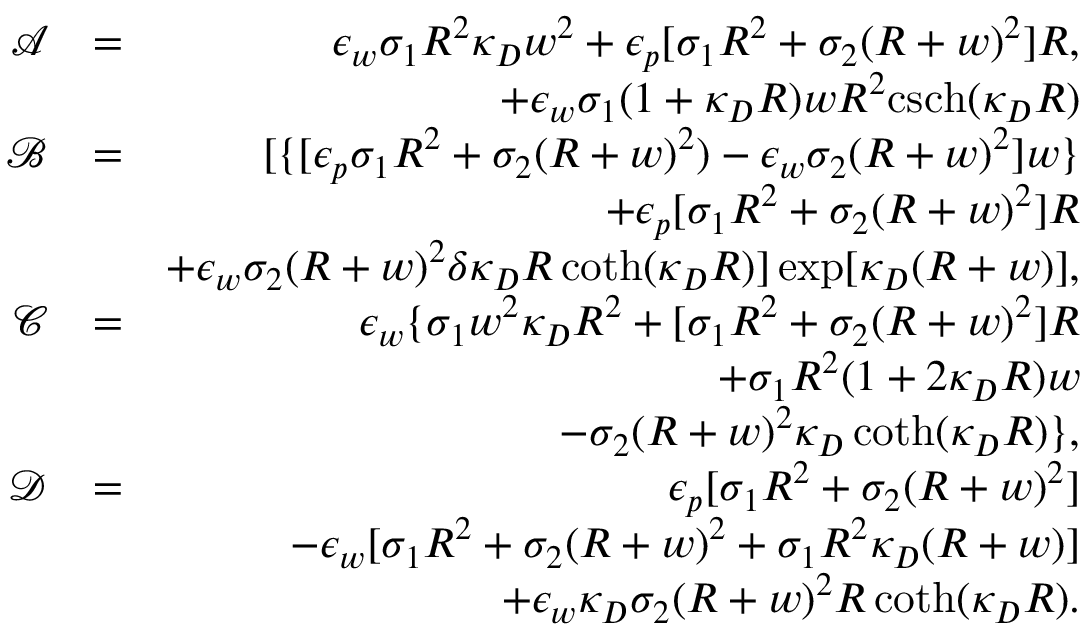Convert formula to latex. <formula><loc_0><loc_0><loc_500><loc_500>\begin{array} { r l r } { \mathcal { A } } & { = } & { \epsilon _ { w } \sigma _ { 1 } R ^ { 2 } \kappa _ { D } w ^ { 2 } + \epsilon _ { p } [ \sigma _ { 1 } R ^ { 2 } + \sigma _ { 2 } ( R + w ) ^ { 2 } ] R , } \\ & { + \epsilon _ { w } \sigma _ { 1 } ( 1 + \kappa _ { D } R ) w R ^ { 2 } c s c h ( \kappa _ { D } R ) } \\ { \mathcal { B } } & { = } & { [ \{ [ \epsilon _ { p } \sigma _ { 1 } R ^ { 2 } + \sigma _ { 2 } ( R + w ) ^ { 2 } ) - \epsilon _ { w } \sigma _ { 2 } ( R + w ) ^ { 2 } ] w \} } \\ & { + \epsilon _ { p } [ \sigma _ { 1 } R ^ { 2 } + \sigma _ { 2 } ( R + w ) ^ { 2 } ] R } \\ & { + \epsilon _ { w } \sigma _ { 2 } ( R + w ) ^ { 2 } \delta \kappa _ { D } R \coth ( \kappa _ { D } R ) ] \exp [ \kappa _ { D } ( R + w ) ] , } \\ { \mathcal { C } } & { = } & { \epsilon _ { w } \{ \sigma _ { 1 } w ^ { 2 } \kappa _ { D } R ^ { 2 } + [ \sigma _ { 1 } R ^ { 2 } + \sigma _ { 2 } ( R + w ) ^ { 2 } ] R } \\ & { + \sigma _ { 1 } R ^ { 2 } ( 1 + 2 \kappa _ { D } R ) w } \\ & { - \sigma _ { 2 } ( R + w ) ^ { 2 } \kappa _ { D } \coth ( \kappa _ { D } R ) \} , } \\ { \mathcal { D } } & { = } & { \epsilon _ { p } [ \sigma _ { 1 } R ^ { 2 } + \sigma _ { 2 } ( R + w ) ^ { 2 } ] } \\ & { - \epsilon _ { w } [ \sigma _ { 1 } R ^ { 2 } + \sigma _ { 2 } ( R + w ) ^ { 2 } + \sigma _ { 1 } R ^ { 2 } \kappa _ { D } ( R + w ) ] } \\ & { + \epsilon _ { w } \kappa _ { D } \sigma _ { 2 } ( R + w ) ^ { 2 } R \coth ( \kappa _ { D } R ) . } \end{array}</formula> 